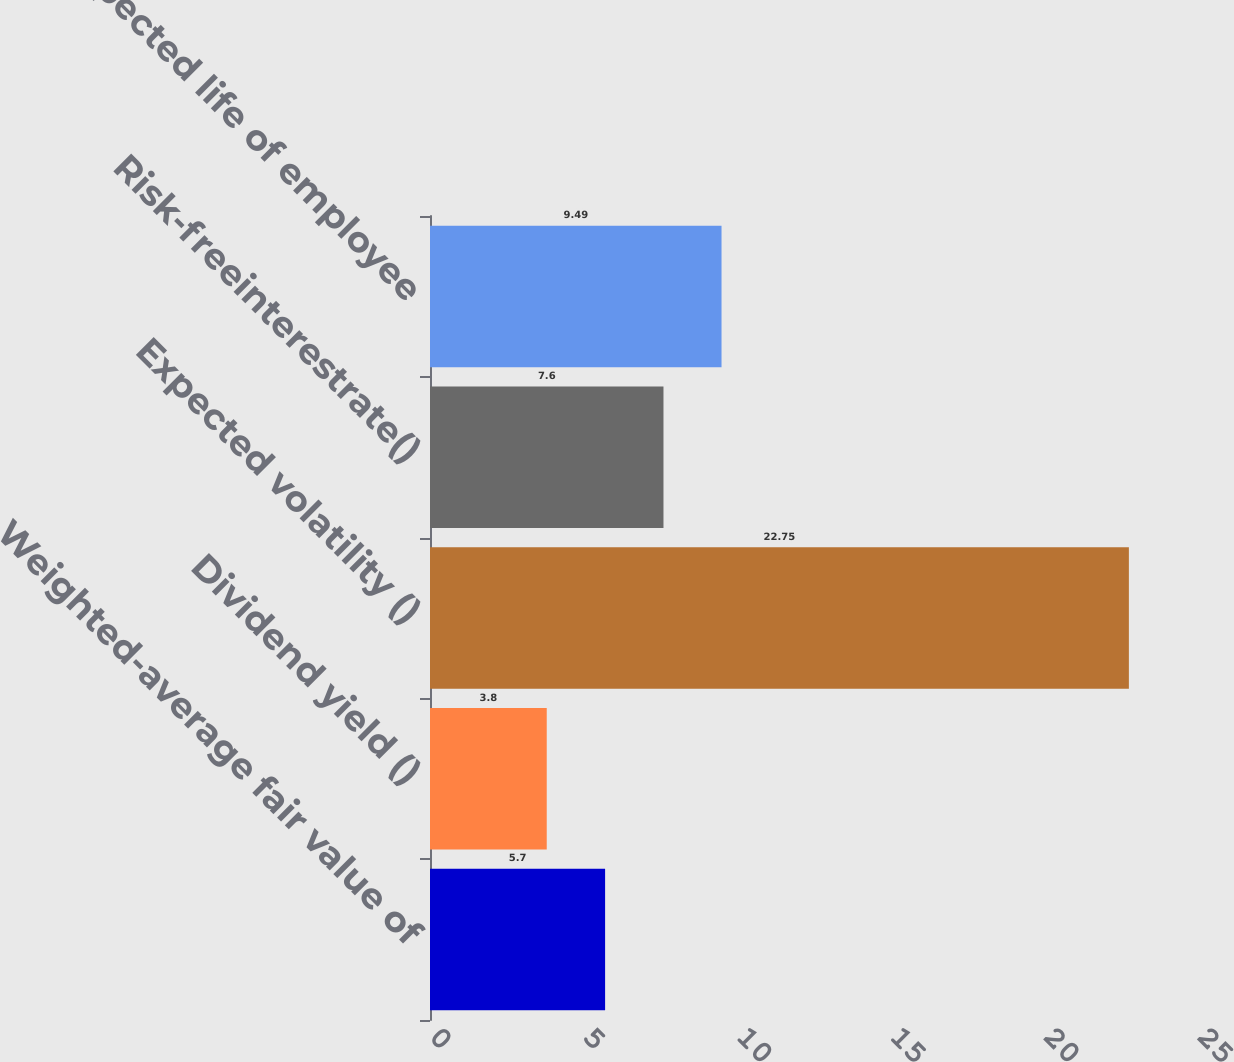Convert chart. <chart><loc_0><loc_0><loc_500><loc_500><bar_chart><fcel>Weighted-average fair value of<fcel>Dividend yield ()<fcel>Expected volatility ()<fcel>Risk-freeinterestrate()<fcel>Expected life of employee<nl><fcel>5.7<fcel>3.8<fcel>22.75<fcel>7.6<fcel>9.49<nl></chart> 